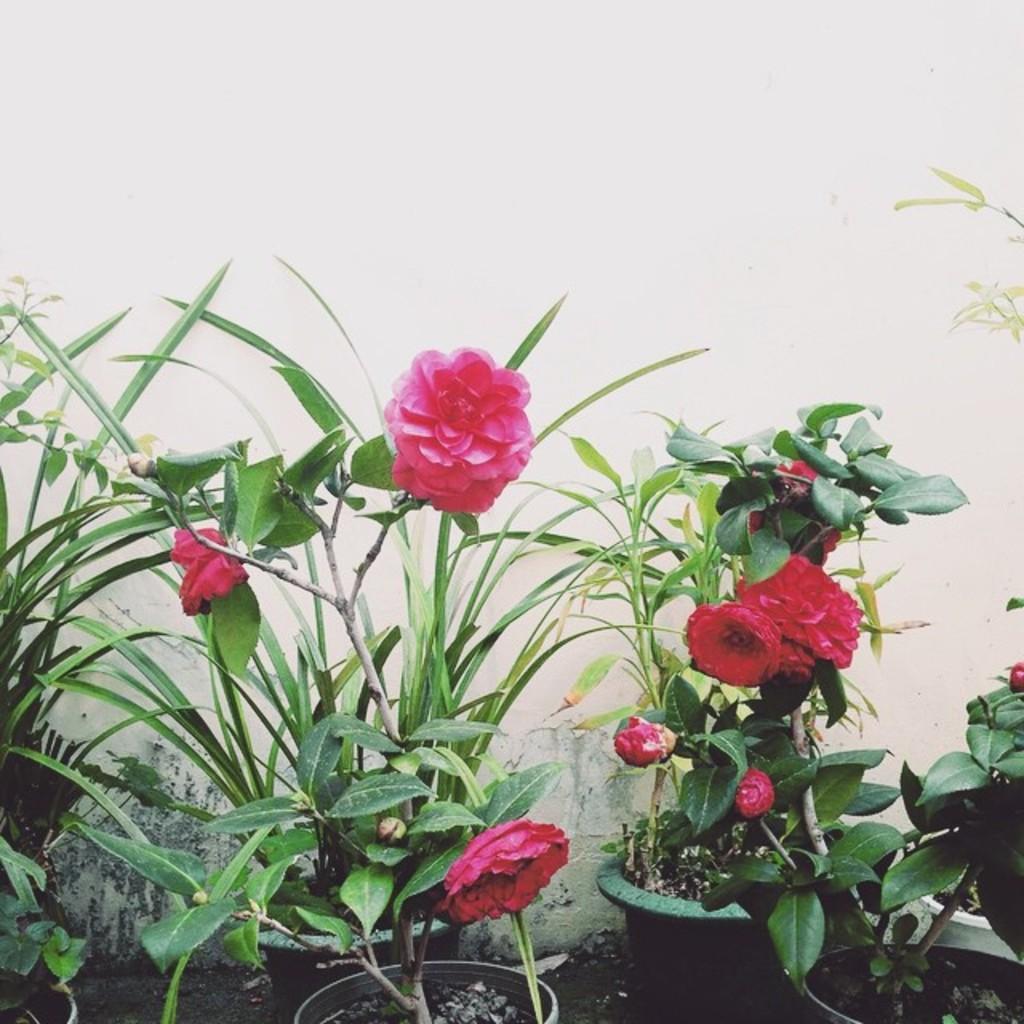Please provide a concise description of this image. In this image there are flowers, flower pots and the wall. 